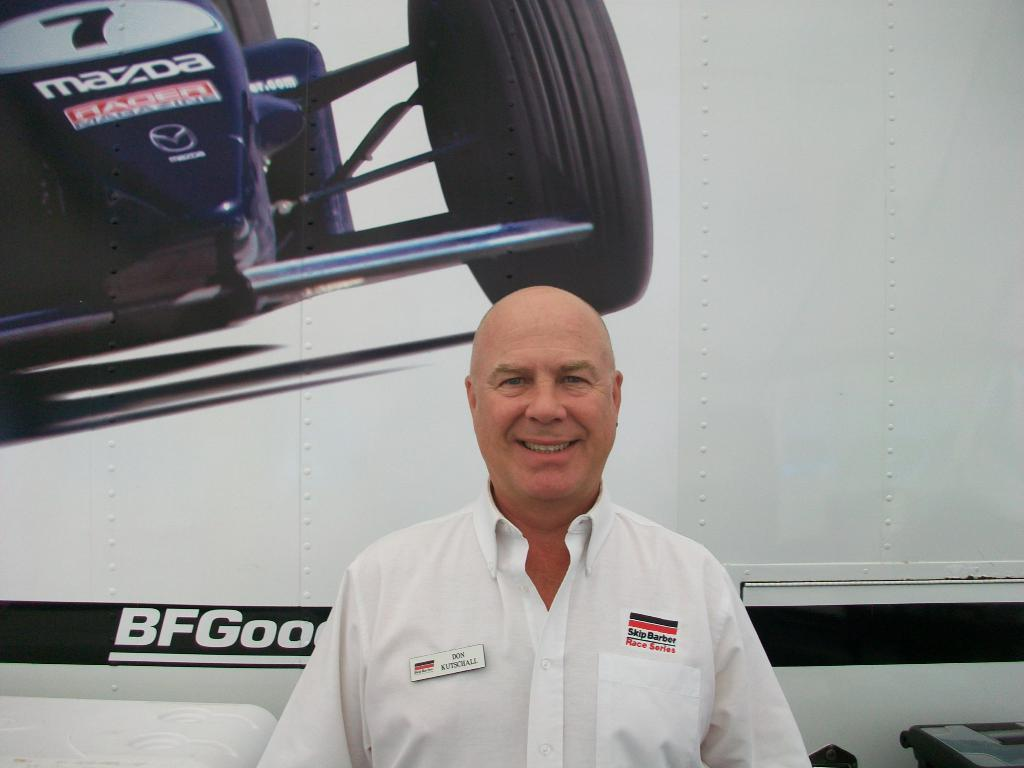<image>
Share a concise interpretation of the image provided. man wearing a shirt with a name tag that says Don Kutschall. 